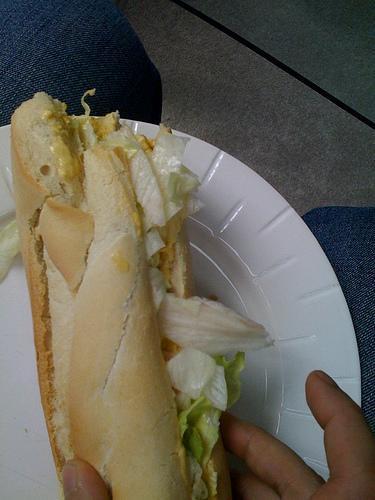How many zebras are facing right in the picture?
Give a very brief answer. 0. 